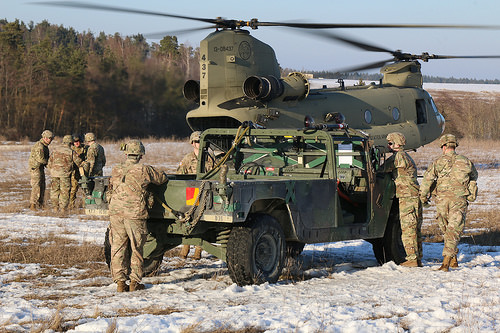<image>
Is the man on the snow? Yes. Looking at the image, I can see the man is positioned on top of the snow, with the snow providing support. Is there a man next to the car? Yes. The man is positioned adjacent to the car, located nearby in the same general area. 